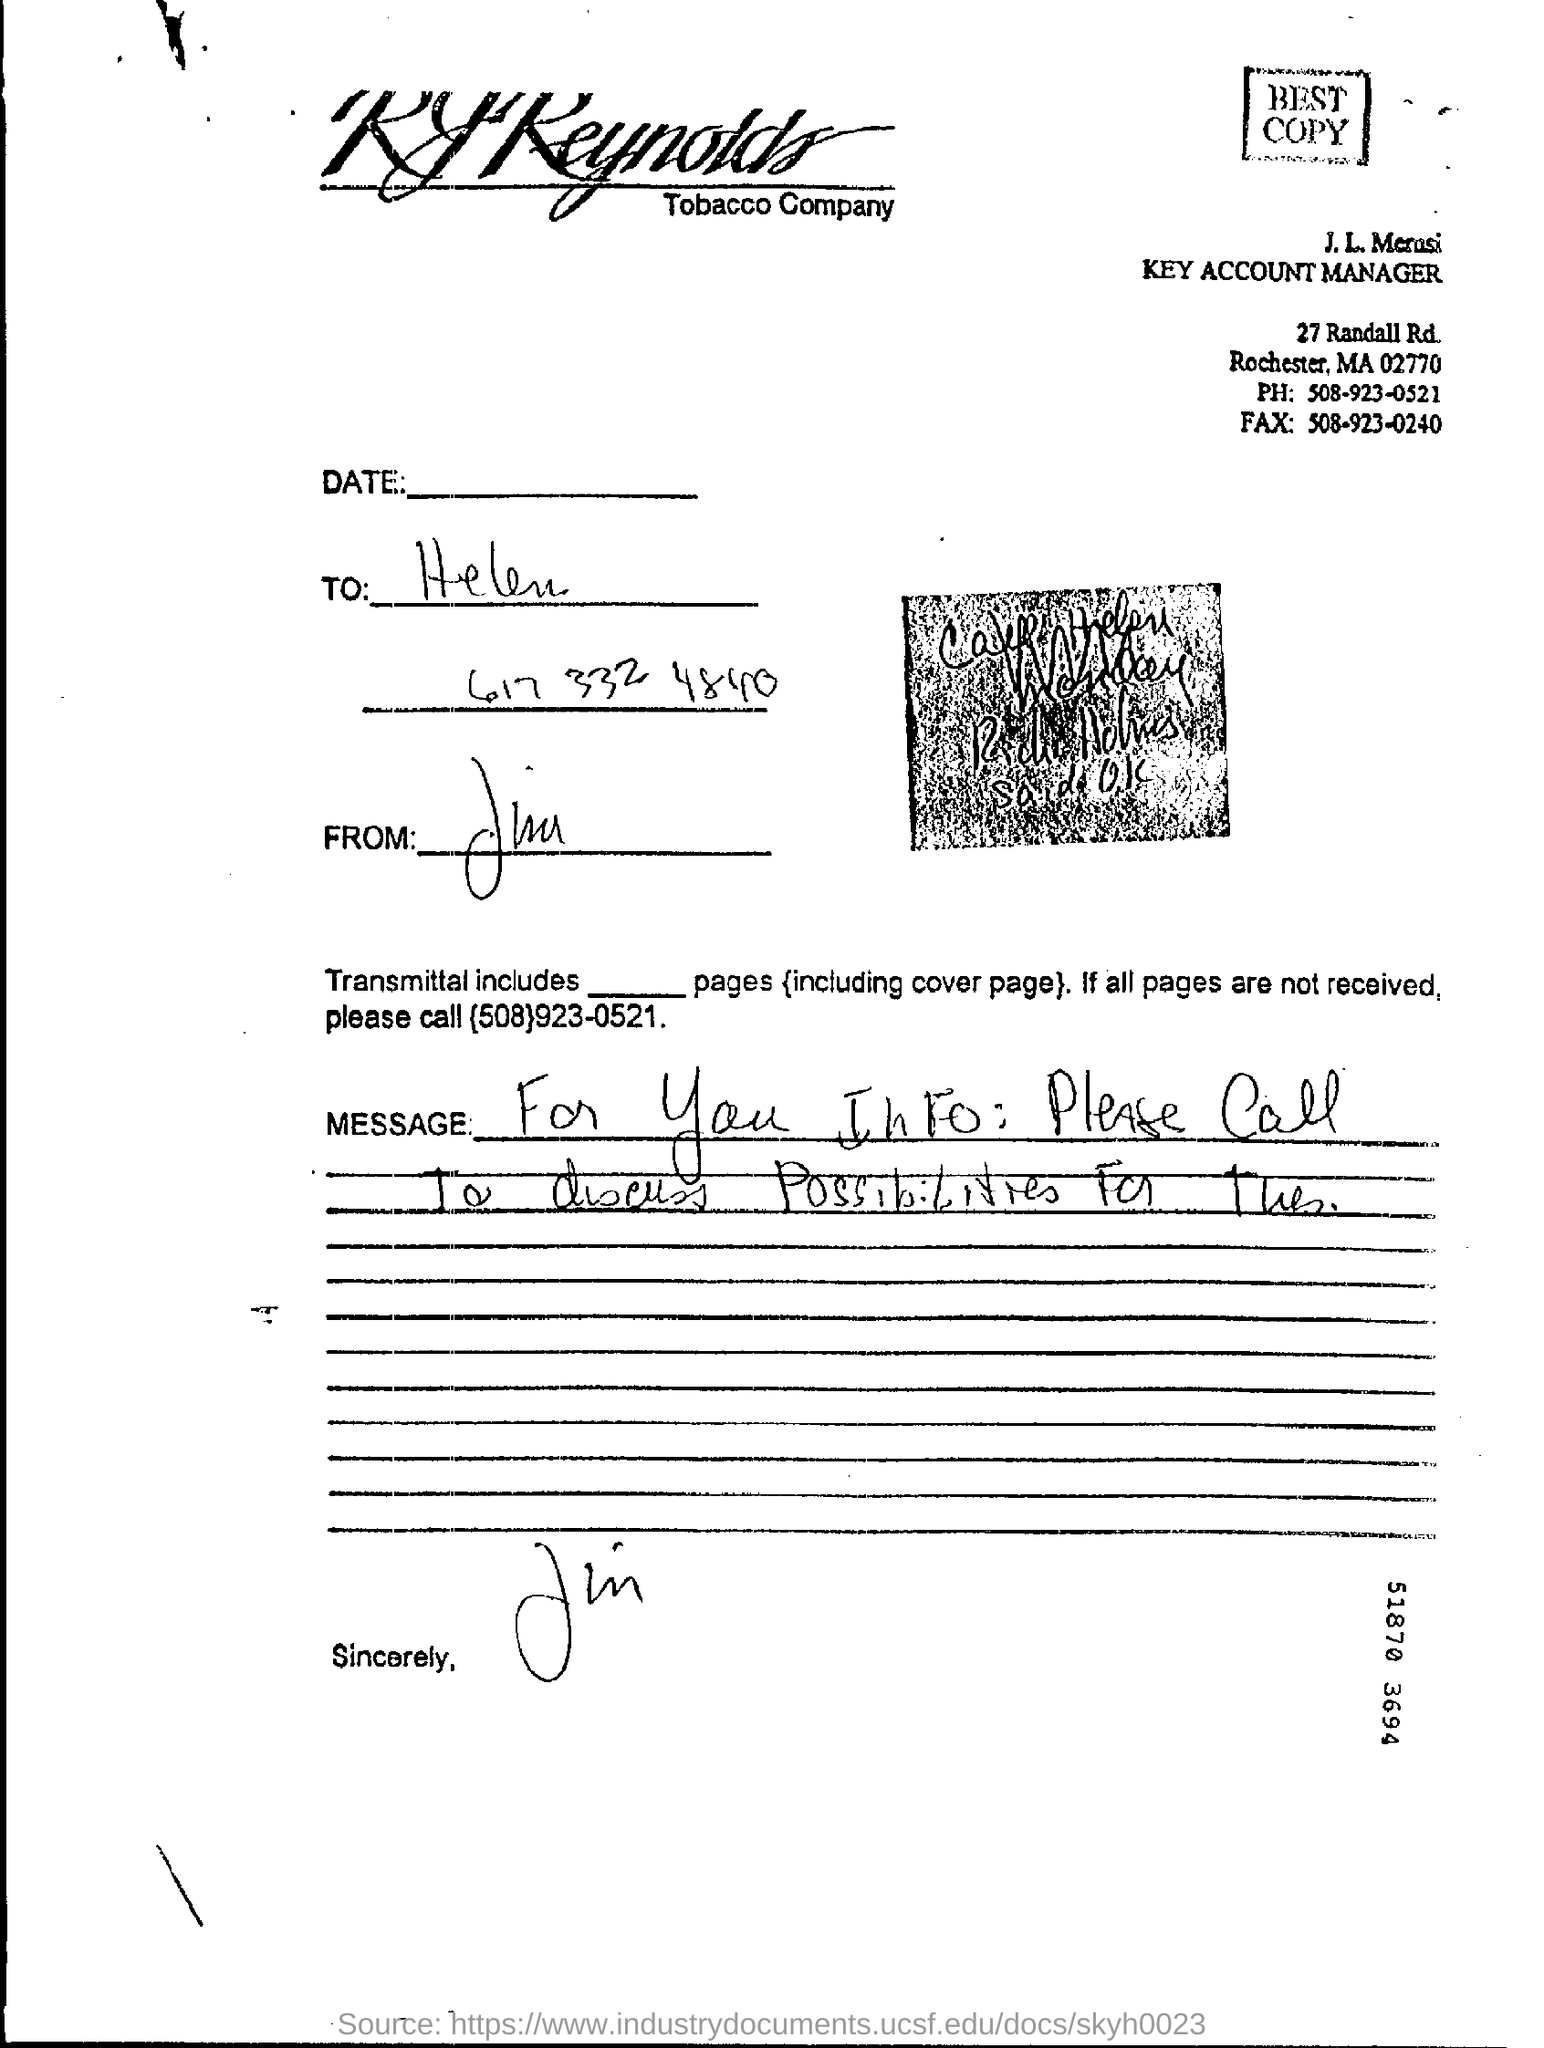what is the phone no mentioned in the letter ?
 508-923-0521 